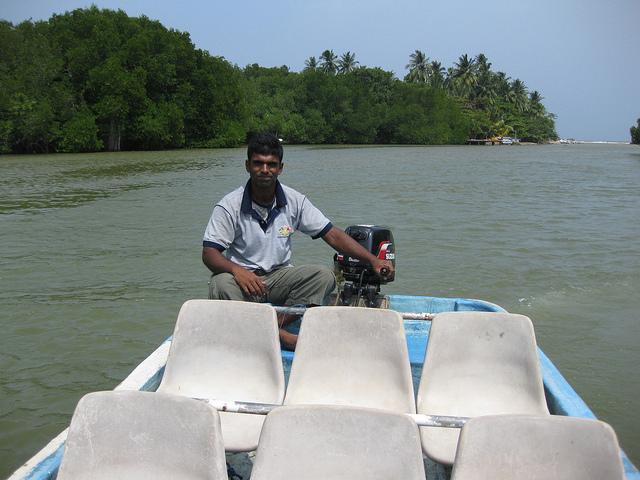How many white seats are shown?
Concise answer only. 6. Is the location a tropical area?
Concise answer only. Yes. Is the photographer operating the boat?
Answer briefly. No. 